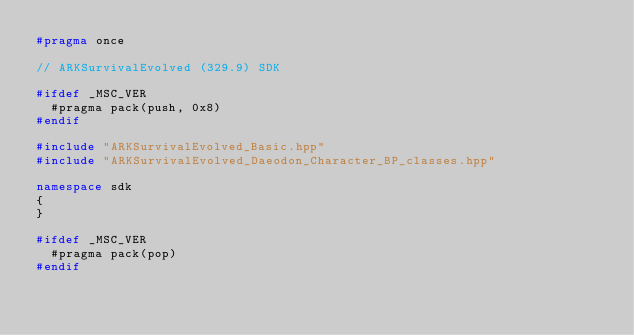Convert code to text. <code><loc_0><loc_0><loc_500><loc_500><_C++_>#pragma once

// ARKSurvivalEvolved (329.9) SDK

#ifdef _MSC_VER
	#pragma pack(push, 0x8)
#endif

#include "ARKSurvivalEvolved_Basic.hpp"
#include "ARKSurvivalEvolved_Daeodon_Character_BP_classes.hpp"

namespace sdk
{
}

#ifdef _MSC_VER
	#pragma pack(pop)
#endif
</code> 